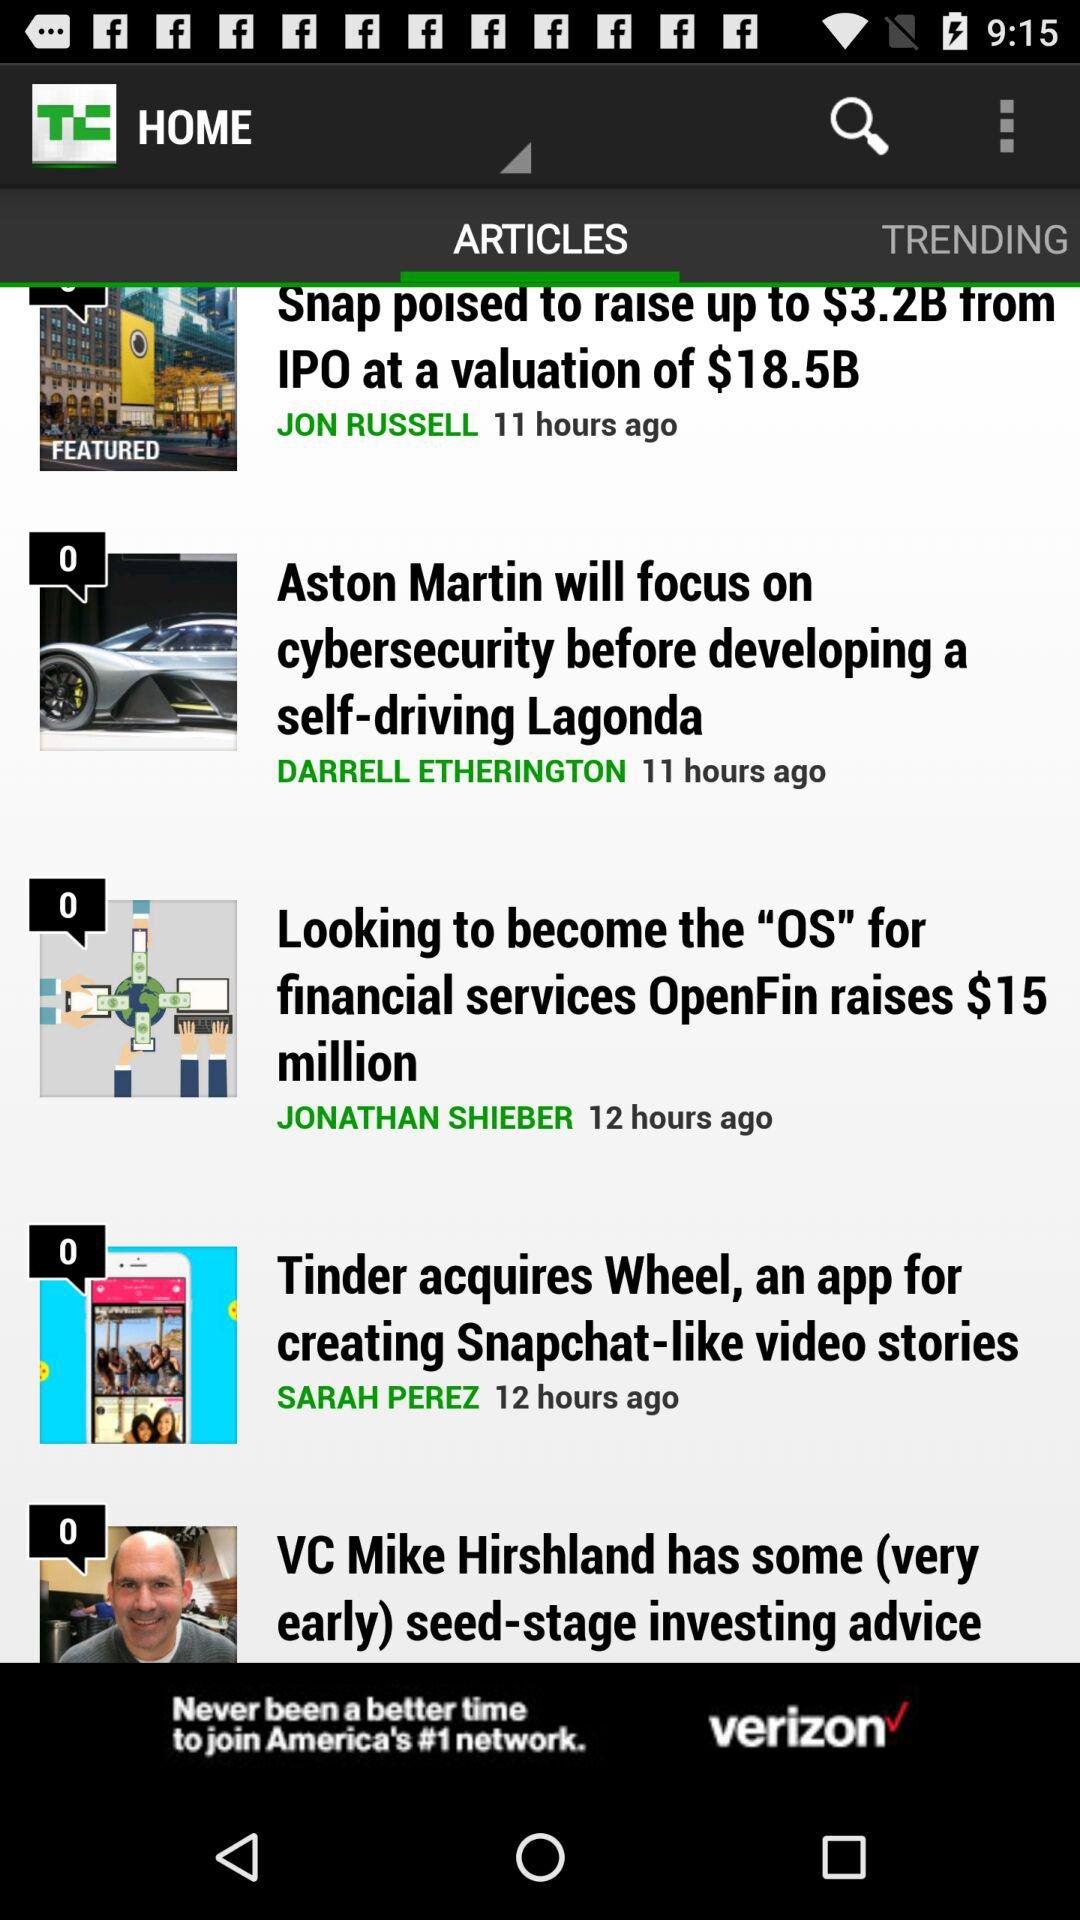What is the author name of "Aston Martin will focus on cybersecurity before developing a self-driving Lagonda"? The author name is Darrell Etherington. 